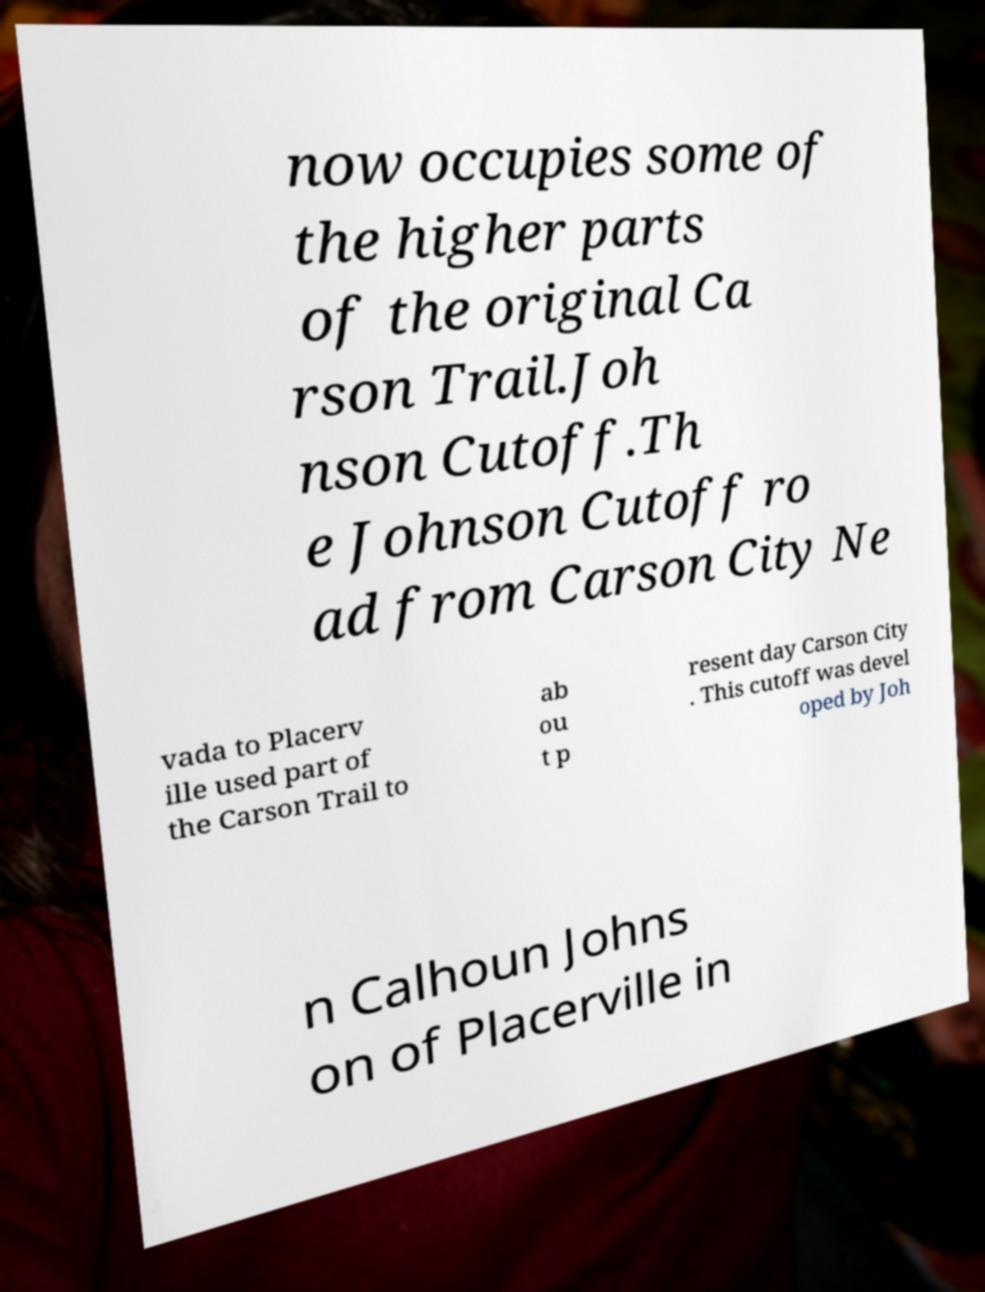What messages or text are displayed in this image? I need them in a readable, typed format. now occupies some of the higher parts of the original Ca rson Trail.Joh nson Cutoff.Th e Johnson Cutoff ro ad from Carson City Ne vada to Placerv ille used part of the Carson Trail to ab ou t p resent day Carson City . This cutoff was devel oped by Joh n Calhoun Johns on of Placerville in 